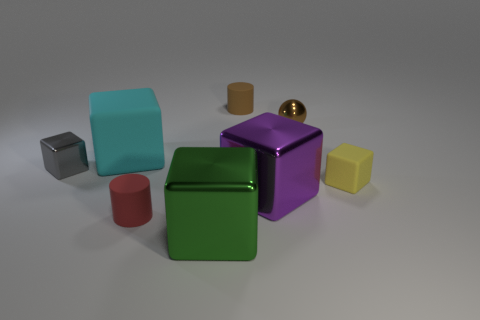Subtract all matte blocks. How many blocks are left? 3 Add 1 big green cylinders. How many objects exist? 9 Subtract all green blocks. How many blocks are left? 4 Subtract all cylinders. How many objects are left? 6 Subtract all small gray matte spheres. Subtract all large shiny cubes. How many objects are left? 6 Add 4 tiny cylinders. How many tiny cylinders are left? 6 Add 7 large cubes. How many large cubes exist? 10 Subtract 0 purple balls. How many objects are left? 8 Subtract all blue cylinders. Subtract all yellow cubes. How many cylinders are left? 2 